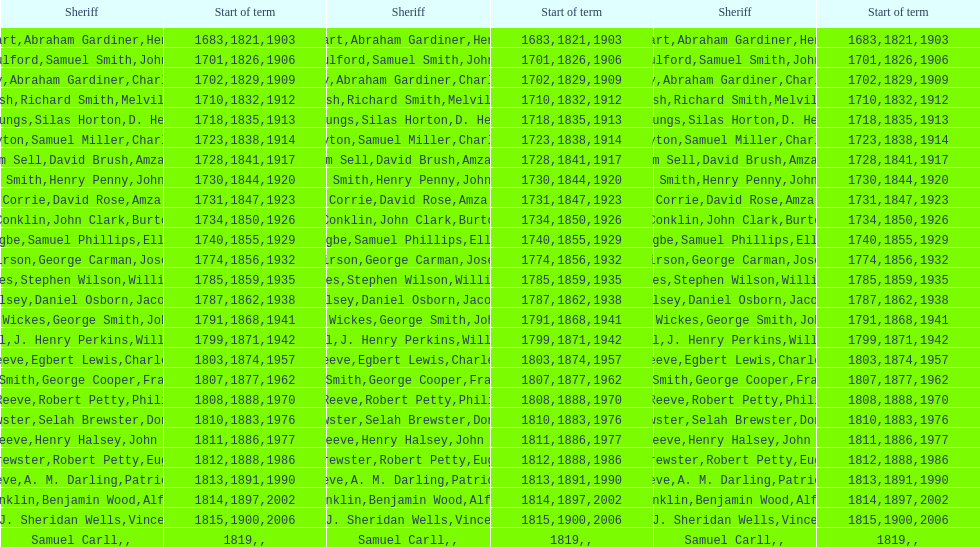Did robert petty serve before josiah reeve? No. 